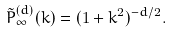<formula> <loc_0><loc_0><loc_500><loc_500>\tilde { P } ^ { ( d ) } _ { \infty } ( k ) = ( 1 + k ^ { 2 } ) ^ { - d / 2 } .</formula> 